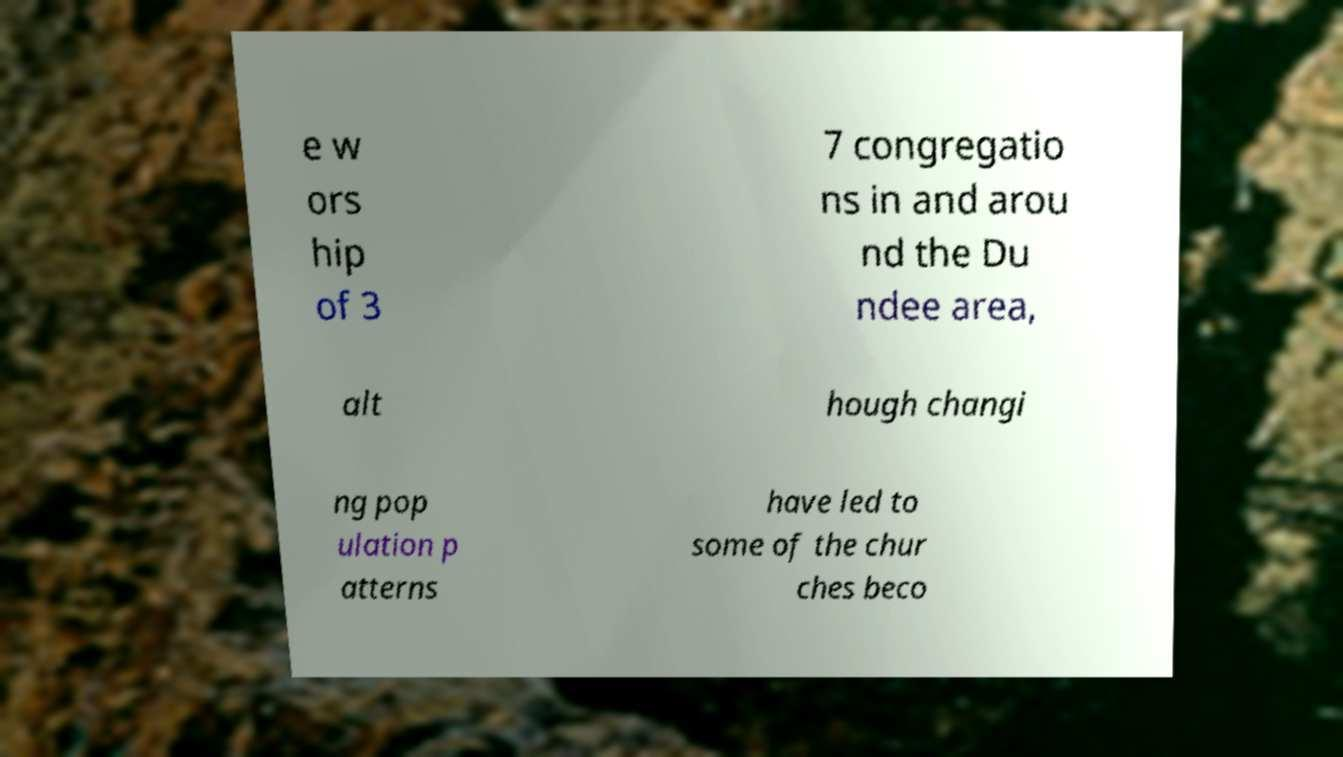I need the written content from this picture converted into text. Can you do that? e w ors hip of 3 7 congregatio ns in and arou nd the Du ndee area, alt hough changi ng pop ulation p atterns have led to some of the chur ches beco 